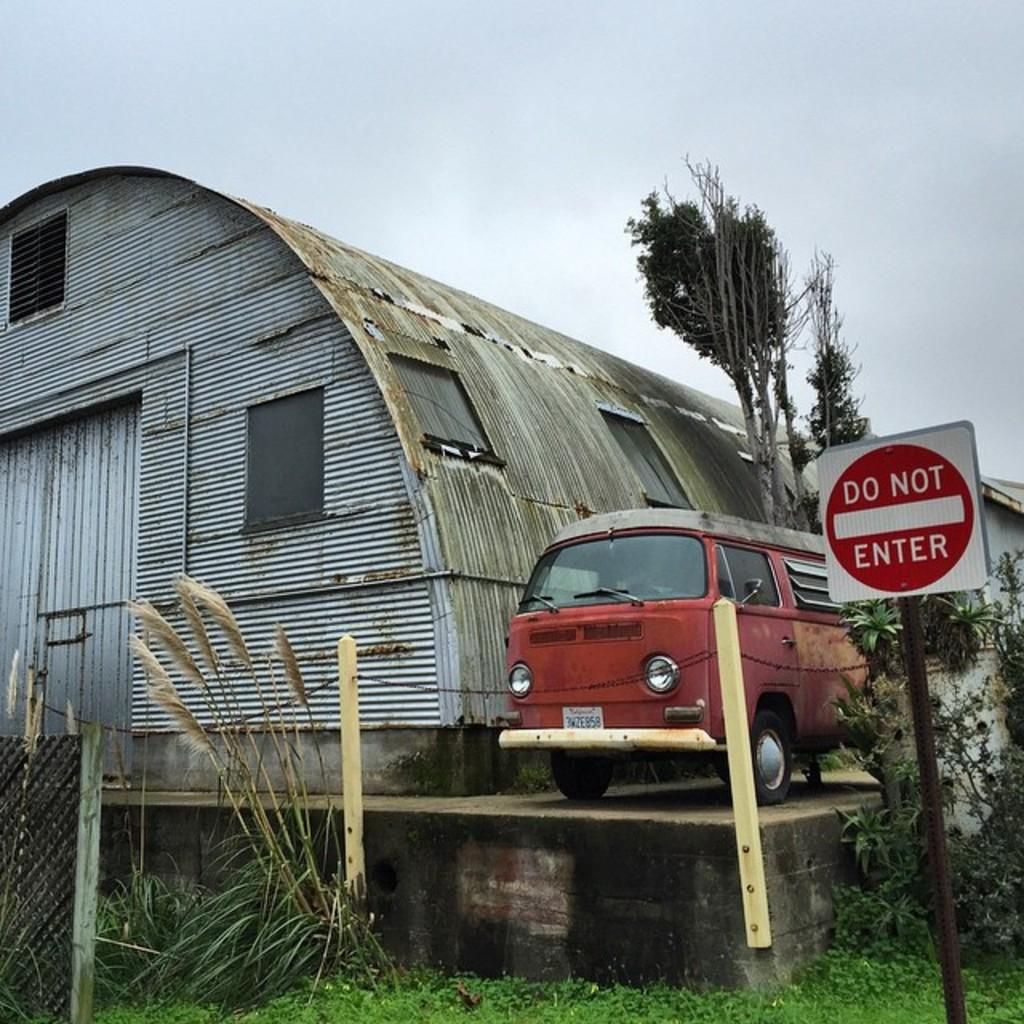What can be seen at the top of the image? The sky is visible at the top of the image. What type of structure is present in the image? There is a shed in the image. What type of vegetation is in the image? There are trees in the image. What type of vehicle is in the image? There is a red van in the image. What type of signage is in the image? There is a sign board in the image. What type of labeling is in the image? There is a net and gross (possibly referring to a sign or label) in the image. How does the harmony between the trees and the shed contribute to the competition in the image? There is no competition present in the image, and the harmony between the trees and the shed is not mentioned as a contributing factor. 